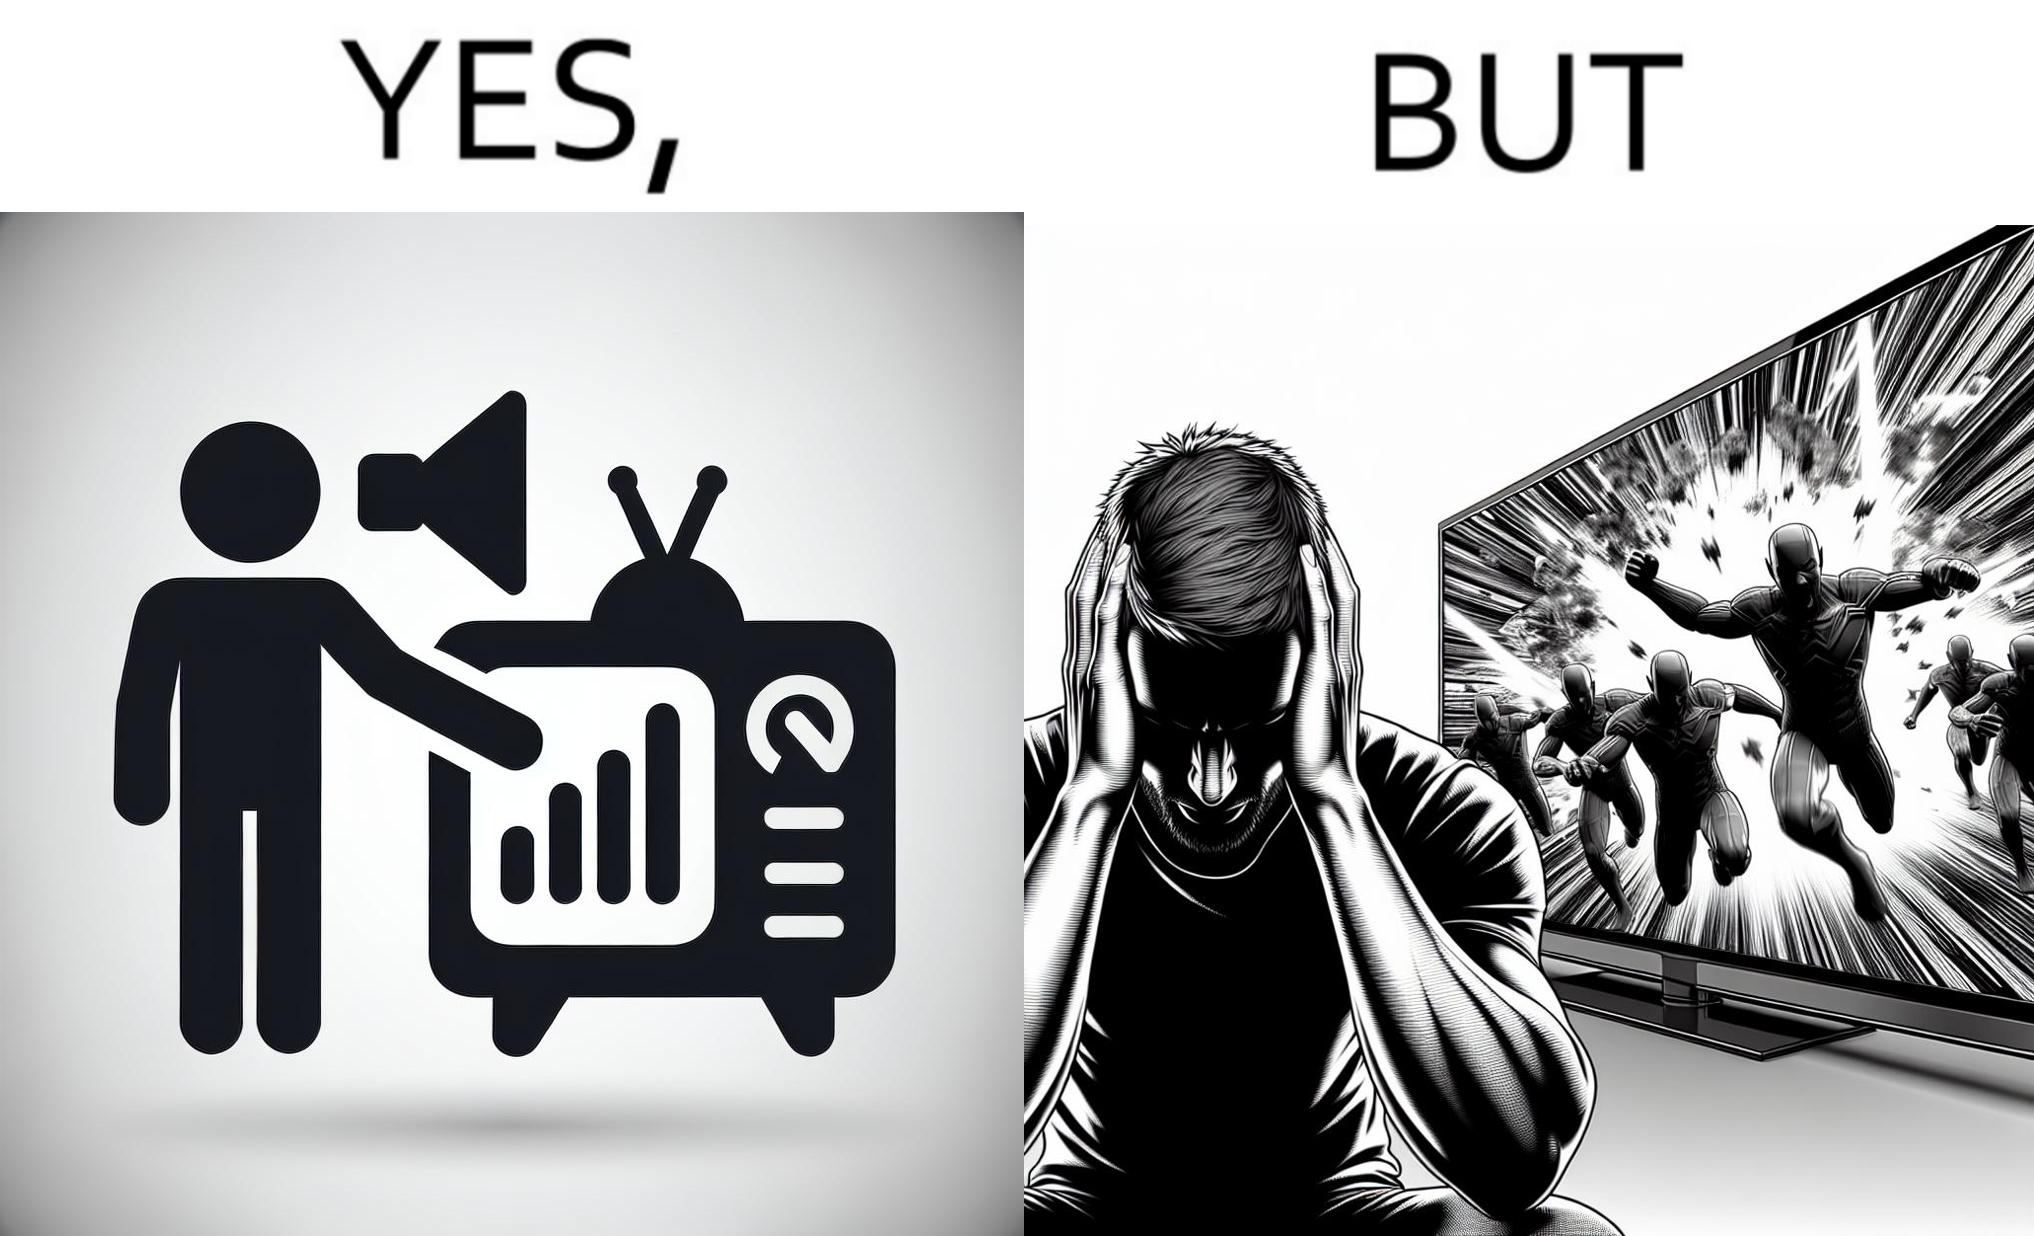Provide a description of this image. The action scenes of the movies or TV programs are mostly low in sound and people aren't able to hear them properly but in the action scenes due to the background music and other noise the sound becomes unbearable to some peoples 